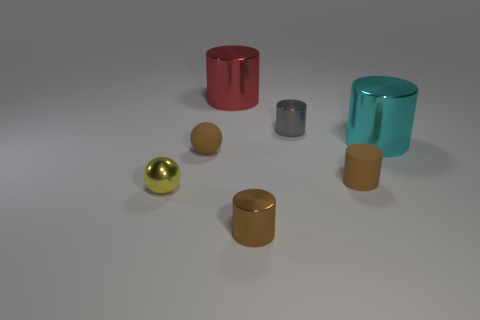Add 2 cyan rubber cylinders. How many objects exist? 9 Subtract all large cylinders. How many cylinders are left? 3 Subtract 1 cylinders. How many cylinders are left? 4 Subtract all cyan cylinders. How many cylinders are left? 4 Subtract all spheres. How many objects are left? 5 Subtract 0 purple balls. How many objects are left? 7 Subtract all yellow cylinders. Subtract all blue spheres. How many cylinders are left? 5 Subtract all red cubes. How many yellow balls are left? 1 Subtract all purple cubes. Subtract all big cyan cylinders. How many objects are left? 6 Add 6 tiny brown objects. How many tiny brown objects are left? 9 